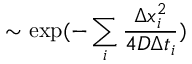Convert formula to latex. <formula><loc_0><loc_0><loc_500><loc_500>\sim \exp ( - \sum _ { i } \frac { \Delta x _ { i } ^ { 2 } } { 4 D \Delta t _ { i } } )</formula> 